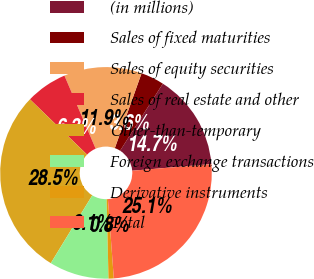Convert chart. <chart><loc_0><loc_0><loc_500><loc_500><pie_chart><fcel>(in millions)<fcel>Sales of fixed maturities<fcel>Sales of equity securities<fcel>Sales of real estate and other<fcel>Other-than-temporary<fcel>Foreign exchange transactions<fcel>Derivative instruments<fcel>Total<nl><fcel>14.65%<fcel>3.57%<fcel>11.88%<fcel>6.34%<fcel>28.5%<fcel>9.11%<fcel>0.8%<fcel>25.14%<nl></chart> 